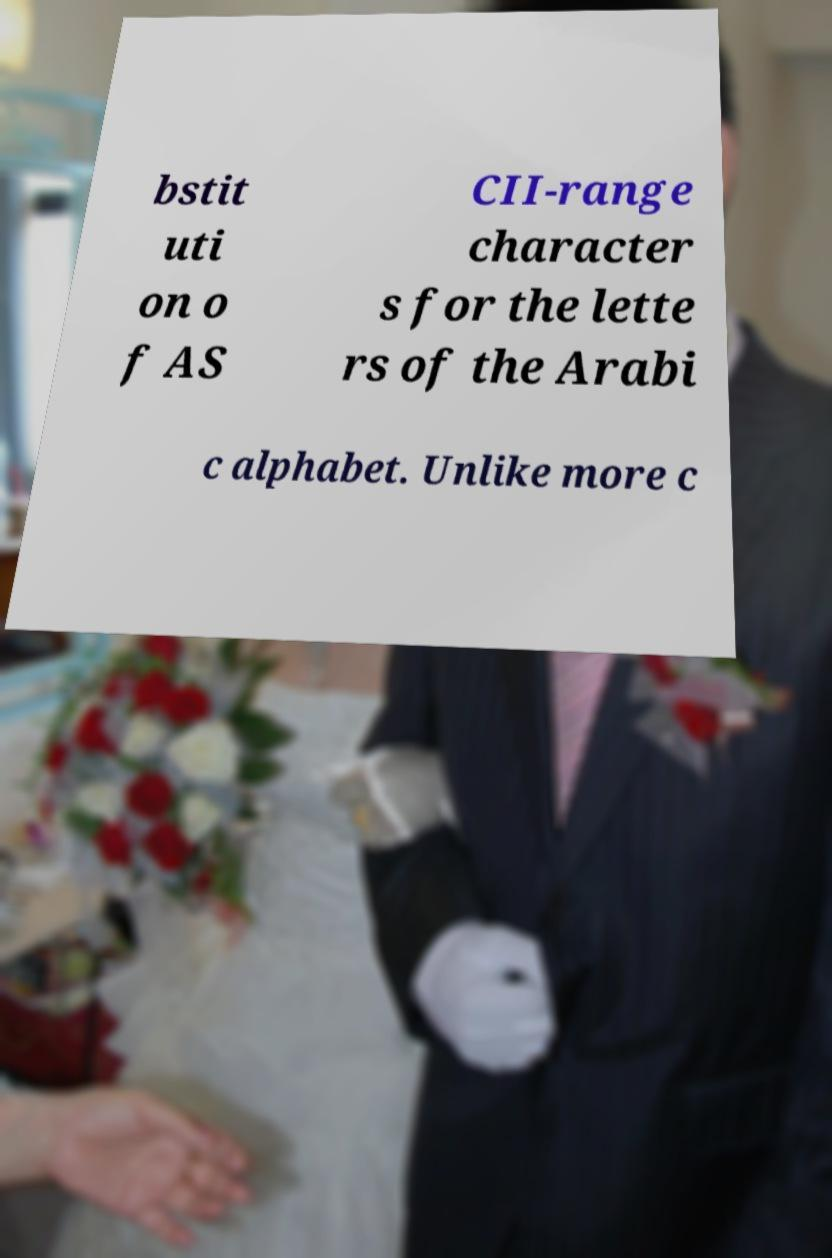Can you accurately transcribe the text from the provided image for me? bstit uti on o f AS CII-range character s for the lette rs of the Arabi c alphabet. Unlike more c 